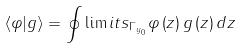<formula> <loc_0><loc_0><loc_500><loc_500>\left \langle \varphi | g \right \rangle = \oint \lim i t s _ { \Gamma _ { y _ { 0 } } } \varphi \left ( z \right ) g \left ( z \right ) d z</formula> 